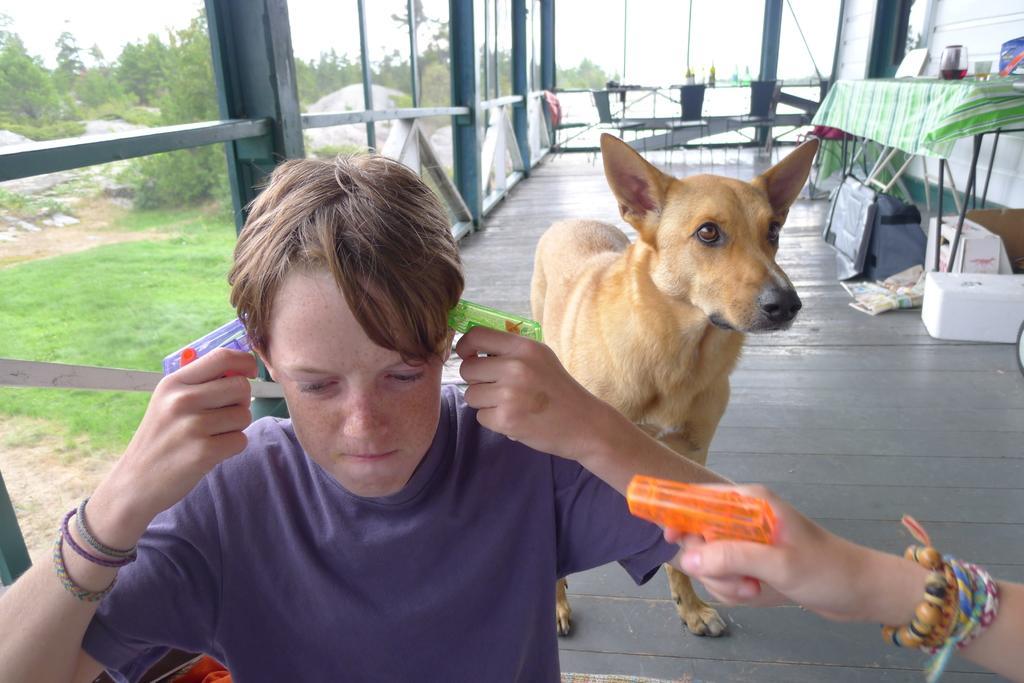Please provide a concise description of this image. In this image I can see the person wearing the purple color dress and holding some objects. I can also see the other person hand. I can see the dog which is in brown color. To the right I can see the table and many objects on it. To the left I can see many trees and the sky. 